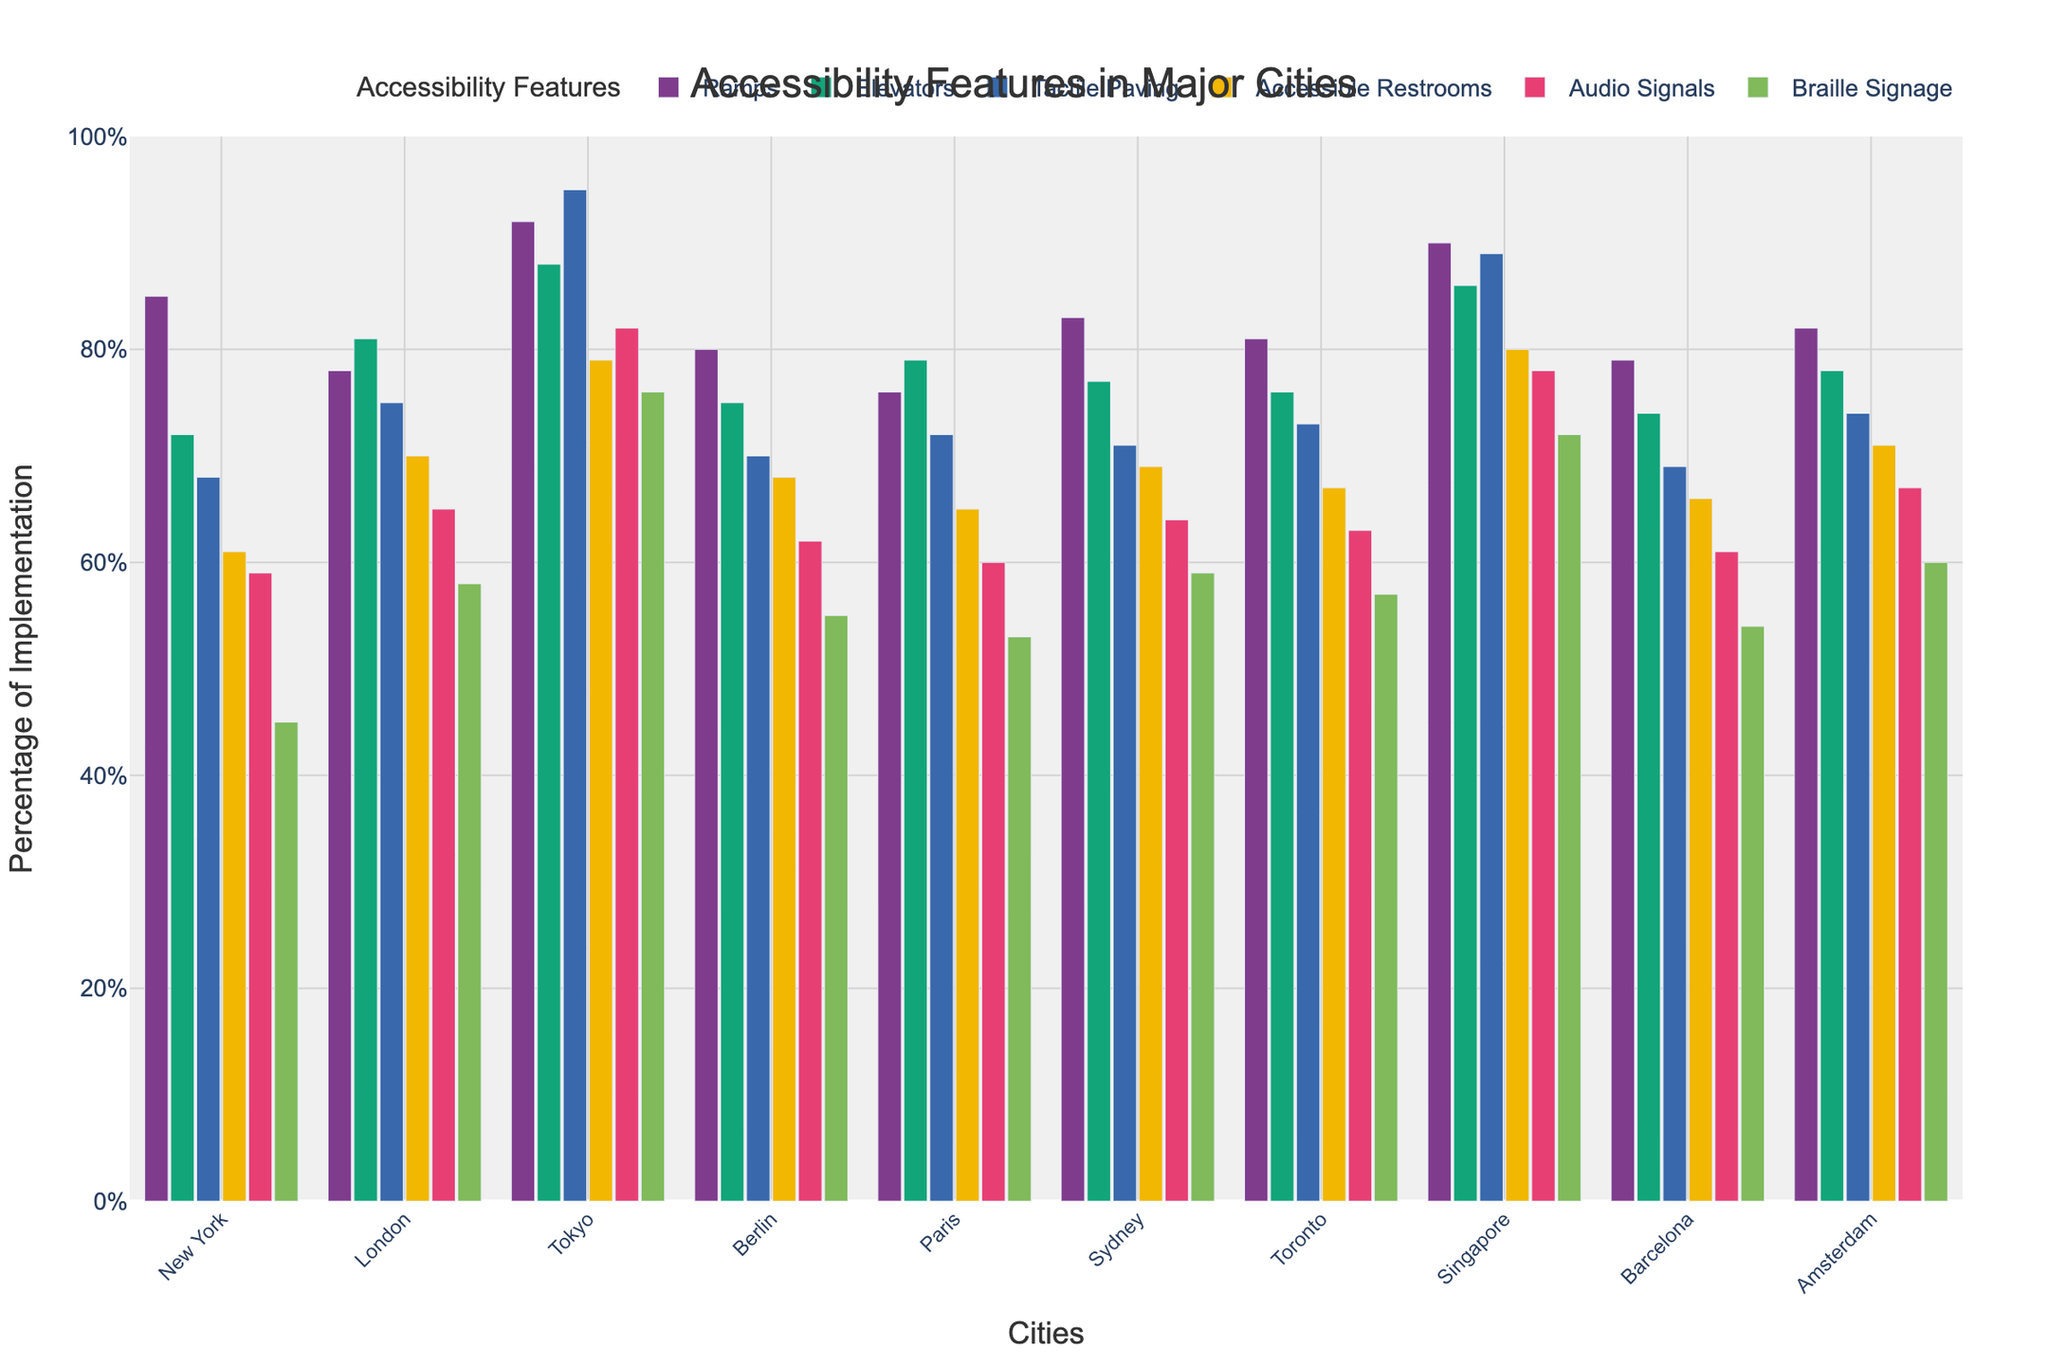What's the city with the highest implementation of tactile paving? To find the city with the highest implementation of tactile paving, compare the tactile paving values for all the cities. Tokyo has the highest value of 95.
Answer: Tokyo Which city has more accessible restrooms, Toronto or Sydney? Compare the values for accessible restrooms between Toronto and Sydney. Sydney has 69% while Toronto has 67%.
Answer: Sydney What is the average percentage of elevator implementation across all cities? Sum the elevator percentages for all cities (72+81+88+75+79+77+76+86+74+78=786) and divide by the number of cities (10). The average is 786/10 = 78.6%.
Answer: 78.6% Which cities have more than 80% implementation of ramps? Identify the cities with ramp percentages greater than 80. These cities are Tokyo (92%), Singapore (90%), and New York (85%).
Answer: Tokyo, Singapore, New York How does the percentage of audio signals in Berlin compare to that in Paris? Compare the audio signals percentages for Berlin and Paris. Berlin has 62% while Paris has 60%. Berlin's percentage is higher.
Answer: Berlin has a higher percentage Which city has the lowest implementation of braille signage? Compare the braille signage values for all the cities. New York has the lowest value of 45%.
Answer: New York What's the difference in the percentages of accessible restrooms between London and Amsterdam? Subtract the Amsterdam value (71%) from the London value (70%). The difference is 71 - 70 = -1%, indicating London has slightly fewer accessible restrooms than Amsterdam.
Answer: -1% How many cities have an implementation percentage of accessible restrooms equal to or greater than 70%? Count the cities with accessible restrooms percentages equal to or greater than 70%. These cities are London, Tokyo, Singapore, and Amsterdam. There are 4 cities.
Answer: 4 What is the sum of percentages of ramps and elevators in Tokyo? Add Tokyo's ramp percentage (92%) to its elevator percentage (88%). The sum is 92 + 88 = 180%.
Answer: 180% Which accessibility feature has the most consistent implementation across all cities? To determine the most consistent feature, observe the variability visually across the bars for each feature. Elevators have relatively less variation across cities compared to other features.
Answer: Elevators 